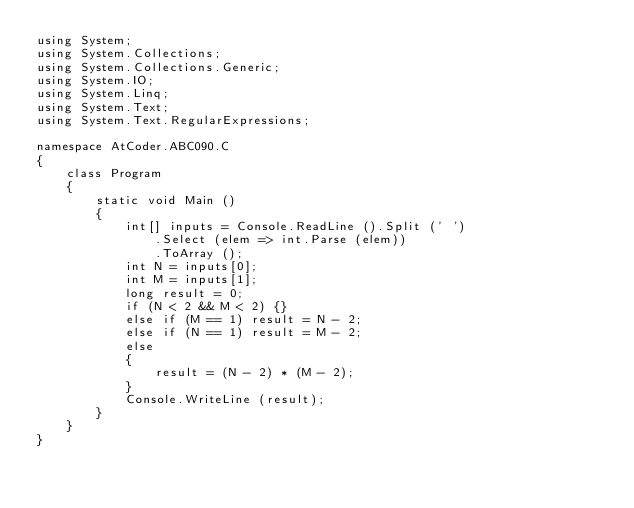Convert code to text. <code><loc_0><loc_0><loc_500><loc_500><_C#_>using System;
using System.Collections;
using System.Collections.Generic;
using System.IO;
using System.Linq;
using System.Text;
using System.Text.RegularExpressions;

namespace AtCoder.ABC090.C
{
    class Program
    {
        static void Main ()
        {
            int[] inputs = Console.ReadLine ().Split (' ')
                .Select (elem => int.Parse (elem))
                .ToArray ();
            int N = inputs[0];
            int M = inputs[1];
            long result = 0;
            if (N < 2 && M < 2) {}
            else if (M == 1) result = N - 2;
            else if (N == 1) result = M - 2;
            else
            {
                result = (N - 2) * (M - 2);
            }
            Console.WriteLine (result);
        }
    }
}</code> 